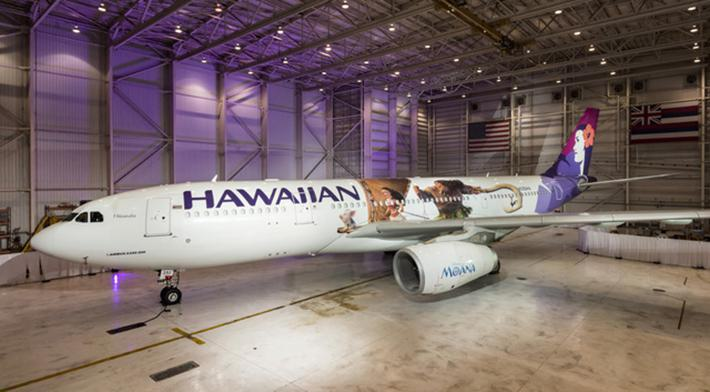How many unicorns are there in the image? There are no unicorns in the image. The photo features an airplane in a hangar with Hawaiian Air livery, indicative of the airline's branding and focus on travel to and from the Hawaiian Islands. 